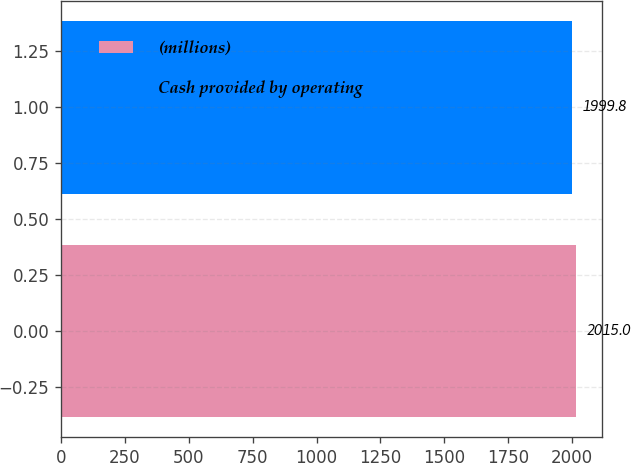Convert chart. <chart><loc_0><loc_0><loc_500><loc_500><bar_chart><fcel>(millions)<fcel>Cash provided by operating<nl><fcel>2015<fcel>1999.8<nl></chart> 